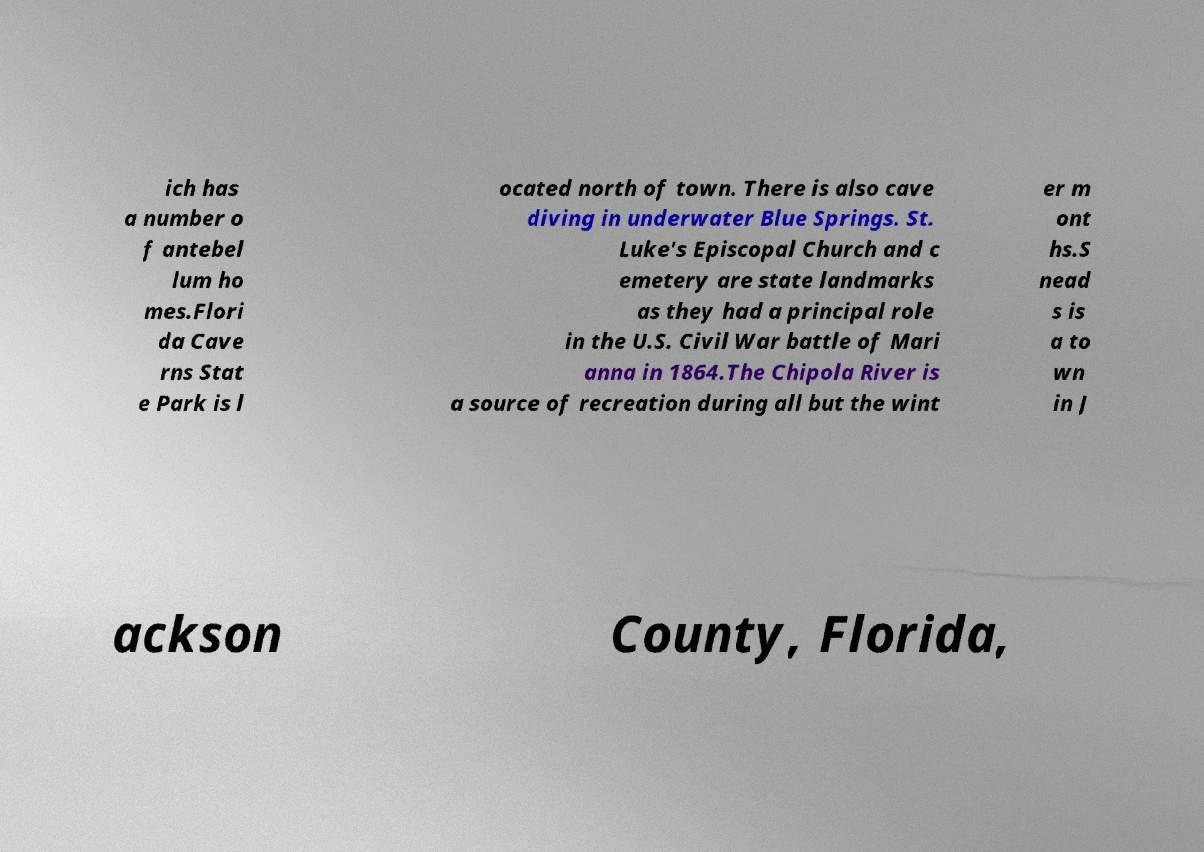What messages or text are displayed in this image? I need them in a readable, typed format. ich has a number o f antebel lum ho mes.Flori da Cave rns Stat e Park is l ocated north of town. There is also cave diving in underwater Blue Springs. St. Luke's Episcopal Church and c emetery are state landmarks as they had a principal role in the U.S. Civil War battle of Mari anna in 1864.The Chipola River is a source of recreation during all but the wint er m ont hs.S nead s is a to wn in J ackson County, Florida, 